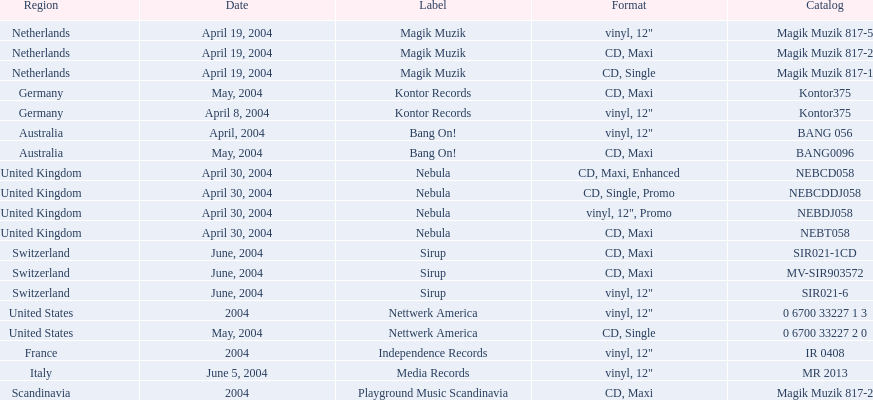Could you help me parse every detail presented in this table? {'header': ['Region', 'Date', 'Label', 'Format', 'Catalog'], 'rows': [['Netherlands', 'April 19, 2004', 'Magik Muzik', 'vinyl, 12"', 'Magik Muzik 817-5'], ['Netherlands', 'April 19, 2004', 'Magik Muzik', 'CD, Maxi', 'Magik Muzik 817-2'], ['Netherlands', 'April 19, 2004', 'Magik Muzik', 'CD, Single', 'Magik Muzik 817-1'], ['Germany', 'May, 2004', 'Kontor Records', 'CD, Maxi', 'Kontor375'], ['Germany', 'April 8, 2004', 'Kontor Records', 'vinyl, 12"', 'Kontor375'], ['Australia', 'April, 2004', 'Bang On!', 'vinyl, 12"', 'BANG 056'], ['Australia', 'May, 2004', 'Bang On!', 'CD, Maxi', 'BANG0096'], ['United Kingdom', 'April 30, 2004', 'Nebula', 'CD, Maxi, Enhanced', 'NEBCD058'], ['United Kingdom', 'April 30, 2004', 'Nebula', 'CD, Single, Promo', 'NEBCDDJ058'], ['United Kingdom', 'April 30, 2004', 'Nebula', 'vinyl, 12", Promo', 'NEBDJ058'], ['United Kingdom', 'April 30, 2004', 'Nebula', 'CD, Maxi', 'NEBT058'], ['Switzerland', 'June, 2004', 'Sirup', 'CD, Maxi', 'SIR021-1CD'], ['Switzerland', 'June, 2004', 'Sirup', 'CD, Maxi', 'MV-SIR903572'], ['Switzerland', 'June, 2004', 'Sirup', 'vinyl, 12"', 'SIR021-6'], ['United States', '2004', 'Nettwerk America', 'vinyl, 12"', '0 6700 33227 1 3'], ['United States', 'May, 2004', 'Nettwerk America', 'CD, Single', '0 6700 33227 2 0'], ['France', '2004', 'Independence Records', 'vinyl, 12"', 'IR 0408'], ['Italy', 'June 5, 2004', 'Media Records', 'vinyl, 12"', 'MR 2013'], ['Scandinavia', '2004', 'Playground Music Scandinavia', 'CD, Maxi', 'Magik Muzik 817-2']]} What label was the only label to be used by france? Independence Records. 